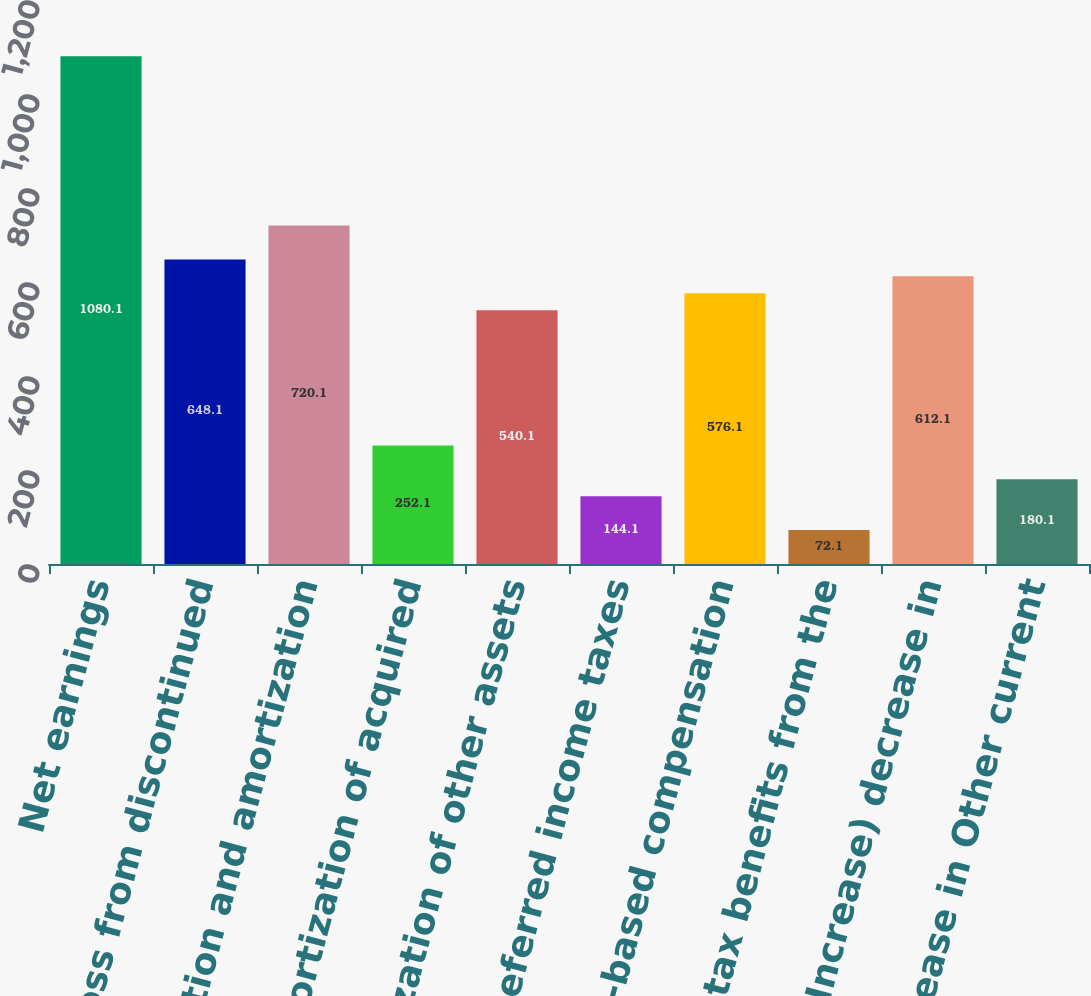Convert chart to OTSL. <chart><loc_0><loc_0><loc_500><loc_500><bar_chart><fcel>Net earnings<fcel>Loss from discontinued<fcel>Depreciation and amortization<fcel>Amortization of acquired<fcel>Amortization of other assets<fcel>Deferred income taxes<fcel>Stock-based compensation<fcel>Excess tax benefits from the<fcel>(Increase) decrease in<fcel>Decrease in Other current<nl><fcel>1080.1<fcel>648.1<fcel>720.1<fcel>252.1<fcel>540.1<fcel>144.1<fcel>576.1<fcel>72.1<fcel>612.1<fcel>180.1<nl></chart> 